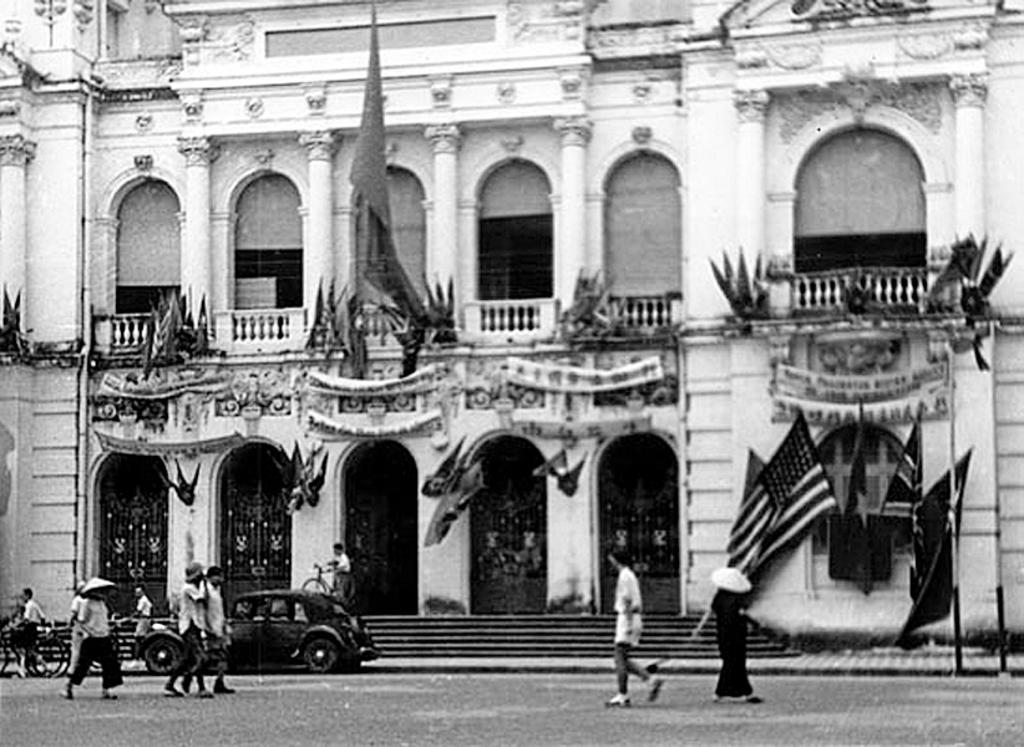What is the color scheme of the image? The image is black and white. What type of structure can be seen in the image? There is a building in the image. What are the flags associated with in the image? The flags are associated with the building in the image. Can you describe the people in the image? There are people in the image, but their specific actions or roles are not clear. What architectural feature is present in the image? There are steps in the image. What else can be seen in the image besides the building and people? There are vehicles and objects in the image. What does the writing on the building say in the image? There is no writing on the building in the image; it is a black and white image with no visible text. 